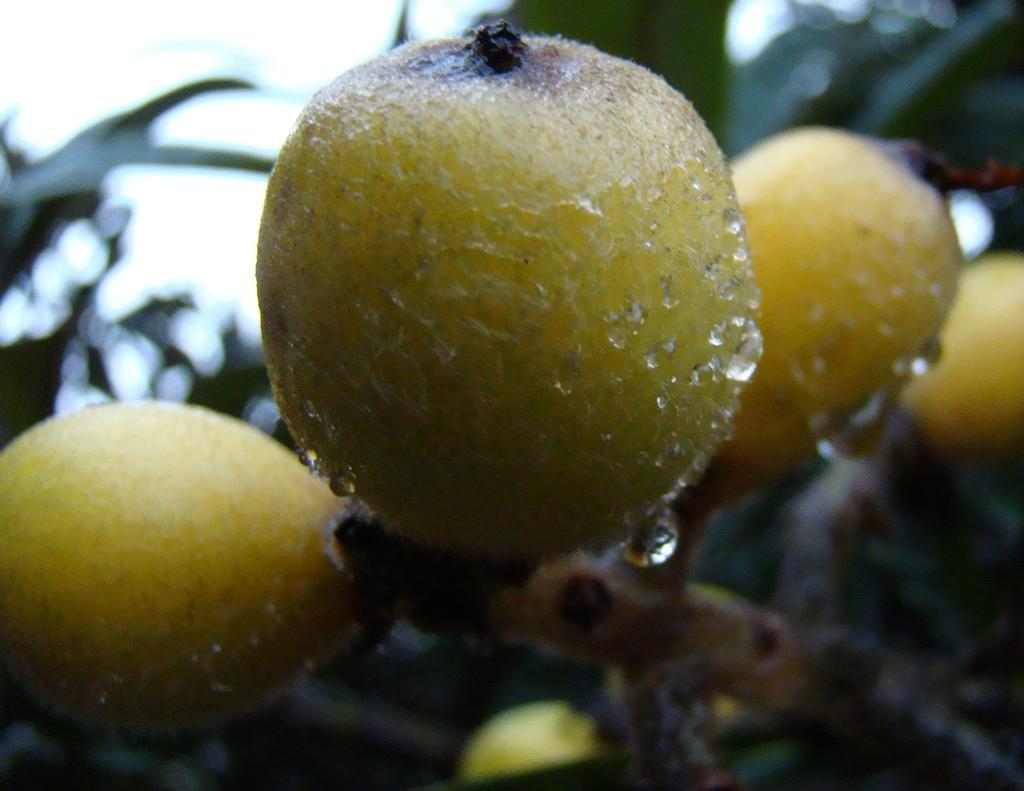What type of food is present in the image? There is a fruit in the image. Can you describe the appearance of the fruit? There are droplets of water on the fruit. What type of grass is being used for the volleyball game in the image? There is no grass or volleyball game present in the image; it only features a fruit with droplets of water. 